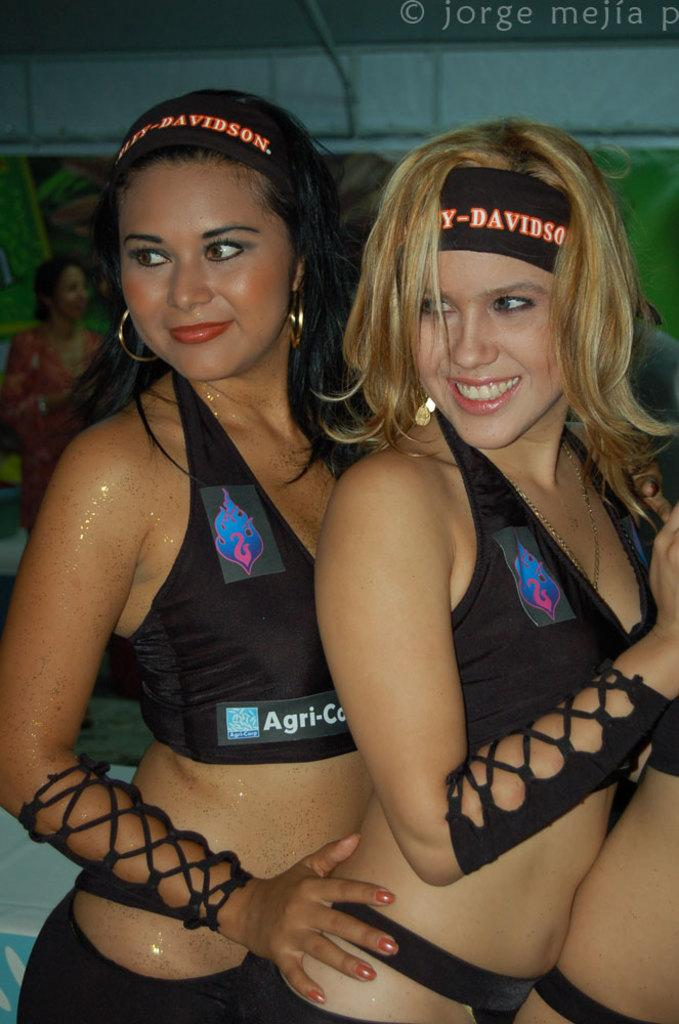Provide a one-sentence caption for the provided image. Two flirtatious woman wear revealing outfits and one sports a Harley-Davidson headband.. 